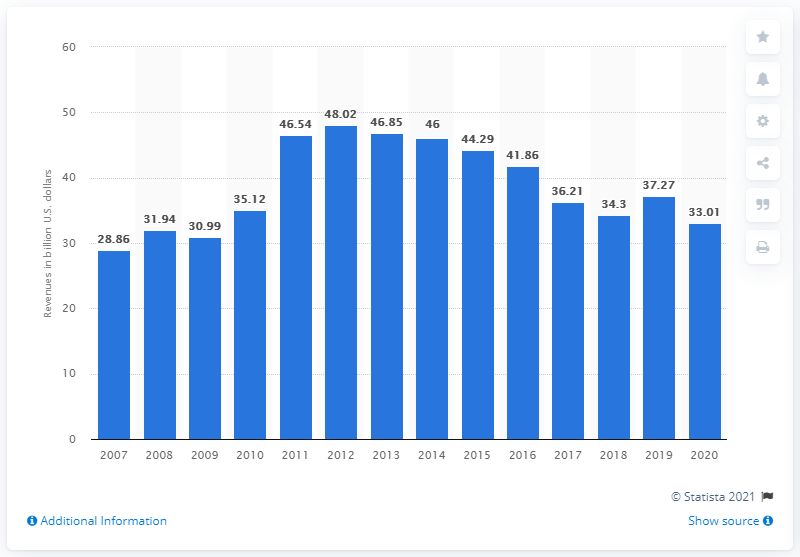Indicate a few pertinent items in this graphic. In 2020, the Coca-Cola Company reported net operating revenues of 33.01. 